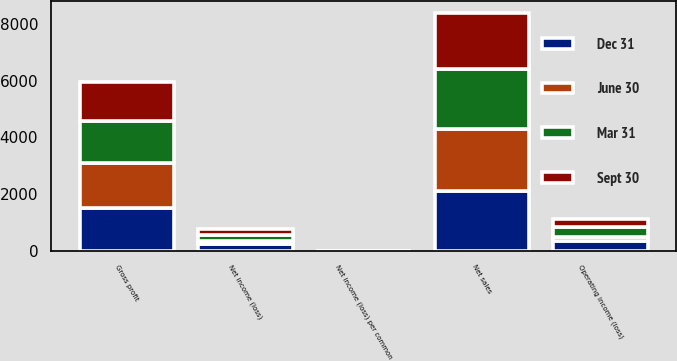<chart> <loc_0><loc_0><loc_500><loc_500><stacked_bar_chart><ecel><fcel>Net sales<fcel>Gross profit<fcel>Operating income (loss)<fcel>Net income (loss)<fcel>Net income (loss) per common<nl><fcel>Sept 30<fcel>1964<fcel>1391<fcel>293<fcel>202<fcel>0.15<nl><fcel>Mar 31<fcel>2126<fcel>1487<fcel>334<fcel>207<fcel>0.15<nl><fcel>Dec 31<fcel>2105<fcel>1511<fcel>348<fcel>228<fcel>0.17<nl><fcel>June 30<fcel>2191<fcel>1572<fcel>140<fcel>124<fcel>0.09<nl></chart> 